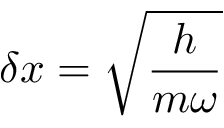Convert formula to latex. <formula><loc_0><loc_0><loc_500><loc_500>\delta x = { \sqrt { \frac { h } { m \omega } } }</formula> 